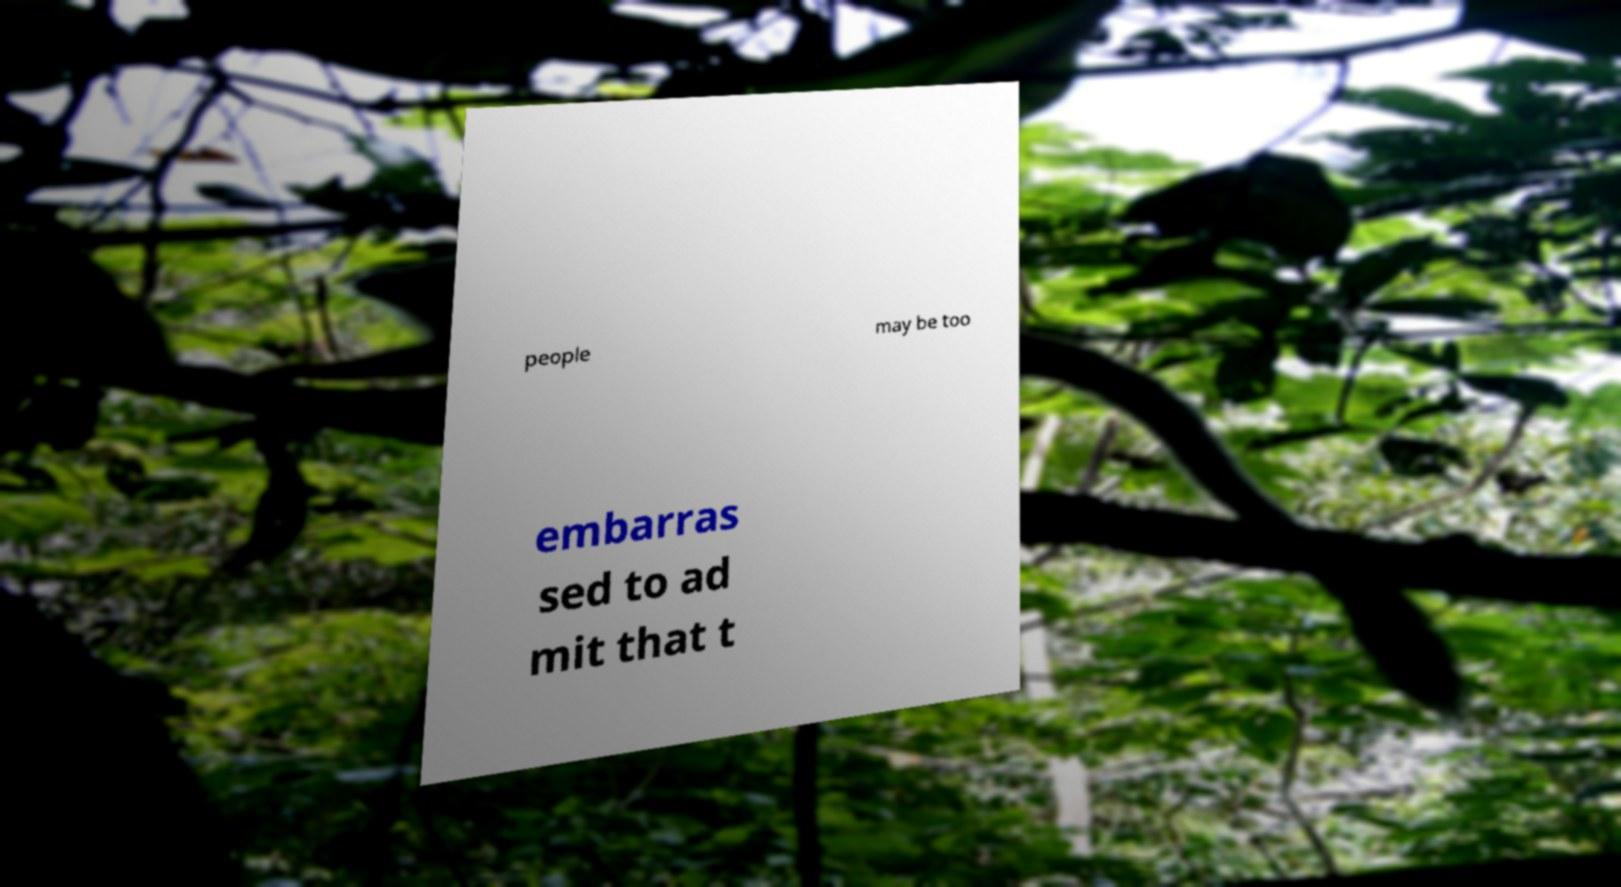Can you read and provide the text displayed in the image?This photo seems to have some interesting text. Can you extract and type it out for me? people may be too embarras sed to ad mit that t 